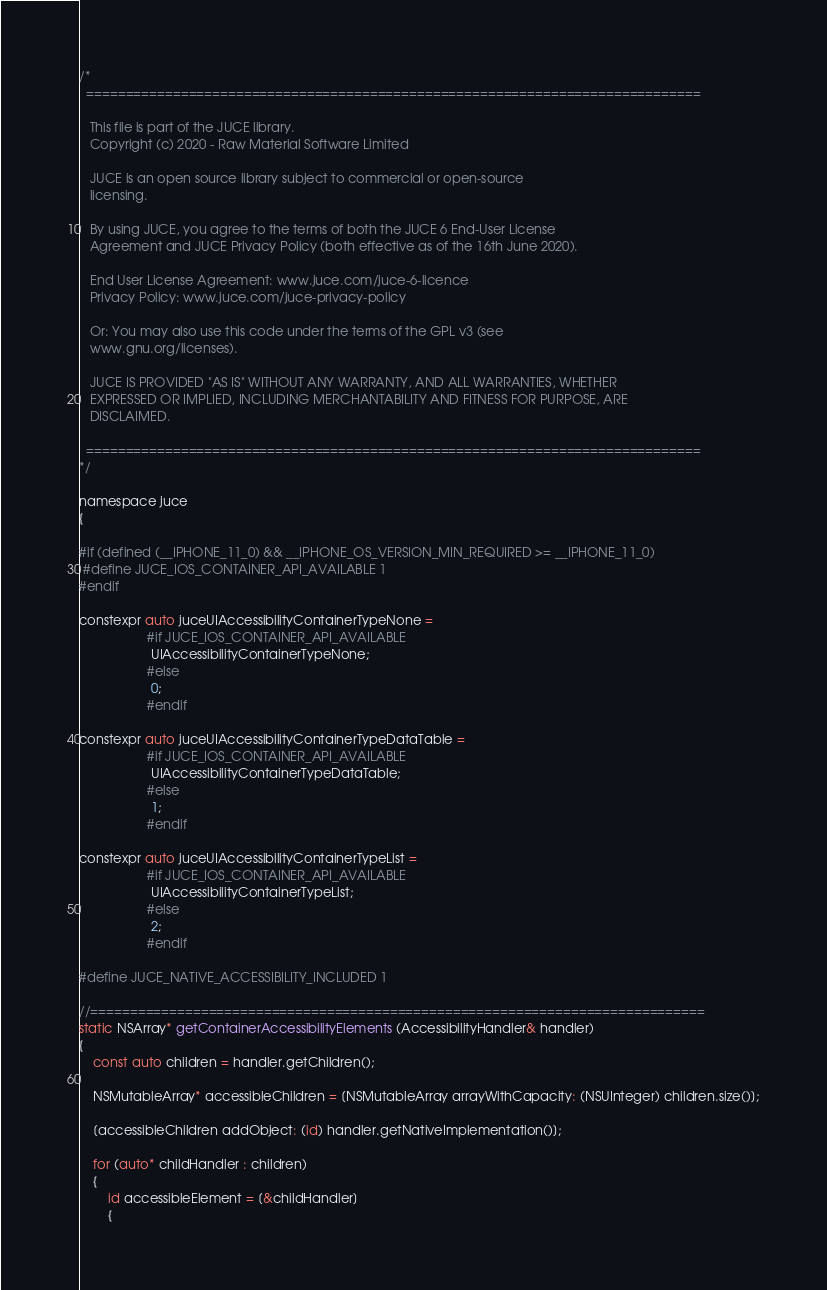Convert code to text. <code><loc_0><loc_0><loc_500><loc_500><_ObjectiveC_>/*
  ==============================================================================

   This file is part of the JUCE library.
   Copyright (c) 2020 - Raw Material Software Limited

   JUCE is an open source library subject to commercial or open-source
   licensing.

   By using JUCE, you agree to the terms of both the JUCE 6 End-User License
   Agreement and JUCE Privacy Policy (both effective as of the 16th June 2020).

   End User License Agreement: www.juce.com/juce-6-licence
   Privacy Policy: www.juce.com/juce-privacy-policy

   Or: You may also use this code under the terms of the GPL v3 (see
   www.gnu.org/licenses).

   JUCE IS PROVIDED "AS IS" WITHOUT ANY WARRANTY, AND ALL WARRANTIES, WHETHER
   EXPRESSED OR IMPLIED, INCLUDING MERCHANTABILITY AND FITNESS FOR PURPOSE, ARE
   DISCLAIMED.

  ==============================================================================
*/

namespace juce
{

#if (defined (__IPHONE_11_0) && __IPHONE_OS_VERSION_MIN_REQUIRED >= __IPHONE_11_0)
 #define JUCE_IOS_CONTAINER_API_AVAILABLE 1
#endif

constexpr auto juceUIAccessibilityContainerTypeNone =
                   #if JUCE_IOS_CONTAINER_API_AVAILABLE
                    UIAccessibilityContainerTypeNone;
                   #else
                    0;
                   #endif

constexpr auto juceUIAccessibilityContainerTypeDataTable =
                   #if JUCE_IOS_CONTAINER_API_AVAILABLE
                    UIAccessibilityContainerTypeDataTable;
                   #else
                    1;
                   #endif

constexpr auto juceUIAccessibilityContainerTypeList =
                   #if JUCE_IOS_CONTAINER_API_AVAILABLE
                    UIAccessibilityContainerTypeList;
                   #else
                    2;
                   #endif

#define JUCE_NATIVE_ACCESSIBILITY_INCLUDED 1

//==============================================================================
static NSArray* getContainerAccessibilityElements (AccessibilityHandler& handler)
{
    const auto children = handler.getChildren();

    NSMutableArray* accessibleChildren = [NSMutableArray arrayWithCapacity: (NSUInteger) children.size()];

    [accessibleChildren addObject: (id) handler.getNativeImplementation()];

    for (auto* childHandler : children)
    {
        id accessibleElement = [&childHandler]
        {</code> 